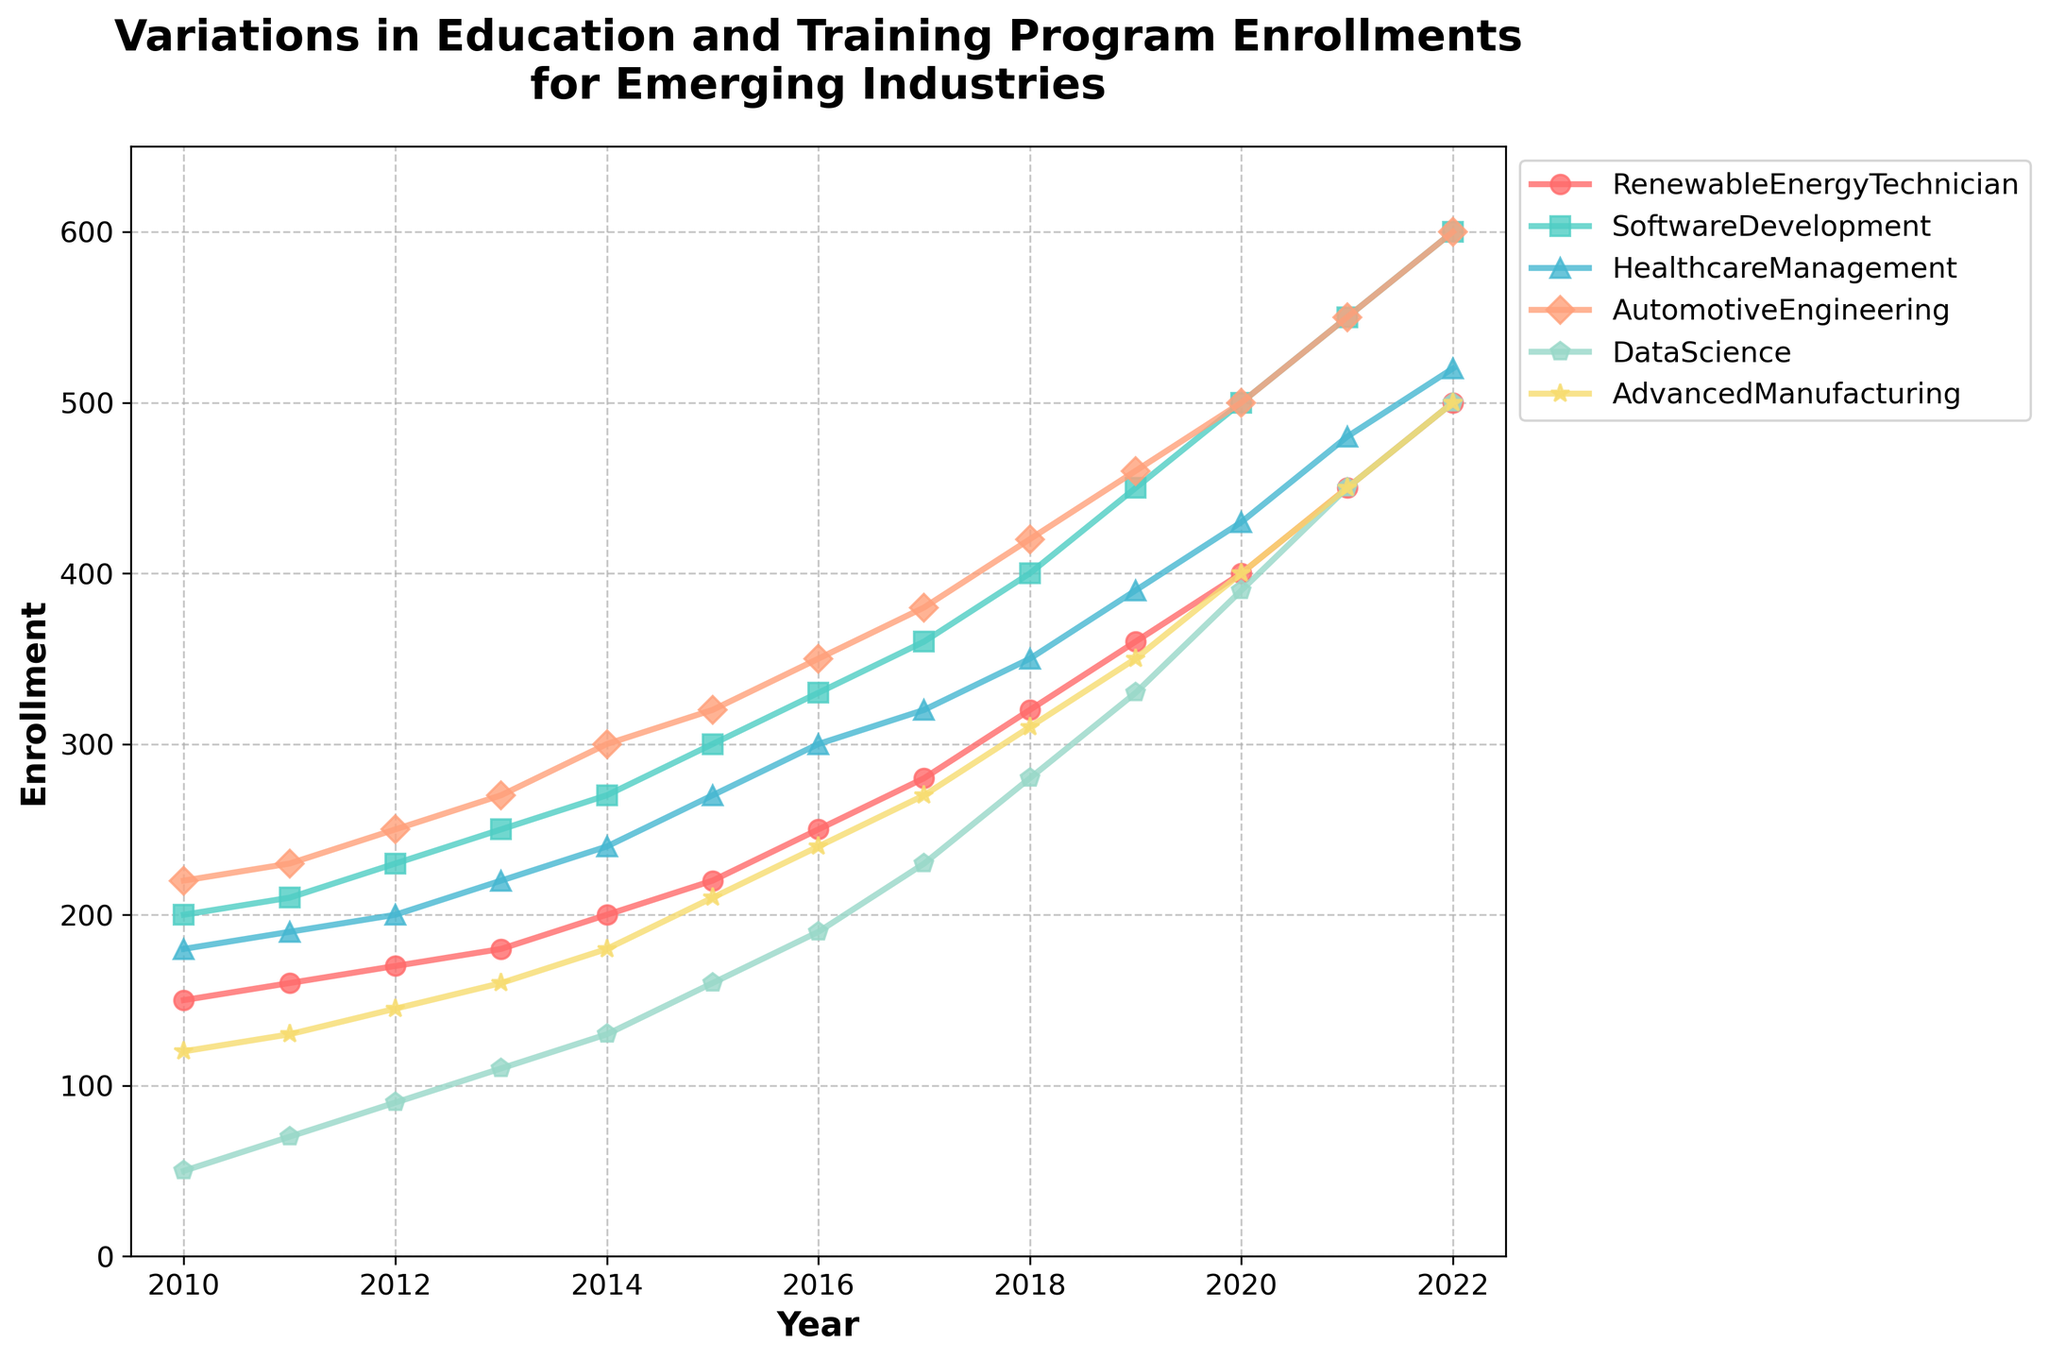What's the title of the figure? The title is usually located at the top of the figure and provides an overview of what the figure represents. The title in this case reads "Variations in Education and Training Program Enrollments for Emerging Industries".
Answer: Variations in Education and Training Program Enrollments for Emerging Industries What is the range of years shown on the x-axis? The x-axis represents the Years from the given data, and the figure shows data ranging from 2010 to 2022. These years are the ticks present along the x-axis.
Answer: 2010 to 2022 Which program had the largest enrollment in the year 2022? To answer this, look at the final data points for each program in 2022. The highest data point corresponds to the "Software Development" program, as it shows 600 enrollments, the highest value in that year.
Answer: Software Development How did the enrollment in Data Science change from 2010 to 2022? In 2010, Data Science had 50 enrollments, and in 2022, it had 500 enrollments. The change, therefore, is the difference between these two values, which is 500 - 50.
Answer: 450 Between which consecutive years did the enrollment for Healthcare Management see the biggest increase? To determine this, look at the year-to-year differences in enrollments for Healthcare Management. The largest increase is between 2014 and 2015, where enrollments jumped from 240 to 270, a difference of 30.
Answer: 2014 to 2015 In which year did Automotive Engineering and Advanced Manufacturing have the same number of enrollments? Look for years where the data points for Automotive Engineering and Advanced Manufacturing overlap. These two programs both had, for instance, 240 enrollments in 2016.
Answer: 2016 What's the average enrollment in Renewable Energy Technician programs over the given years? Sum the enrollments for Renewable Energy Technician over all provided years and divide by the number of years. The sum is 150 + 160 + 170 + 180 + 200 + 220 + 250 + 280 + 320 + 360 + 400 + 450 + 500 = 3640. Divide by 13.
Answer: 280 Which program saw a steady increase in enrollments every year without any decrease or plateau? Examine each series' trajectory. Renewable Energy Technician, Software Development, and Healthcare Management have steady increases every year without any dips.
Answer: Renewable Energy Technician, Software Development, and Healthcare Management What was the total enrollment for all programs in 2020? Sum the data points for all programs in the year 2020: 400 + 500 + 430 + 500 + 390 + 400 = 2620.
Answer: 2620 Which program showed the most significant growth trend overall? Look at the difference between the starting and ending points for each program. Software Development grew from 200 to 600 enrollments, which is the most significant increase (400) compared to other programs.
Answer: Software Development 